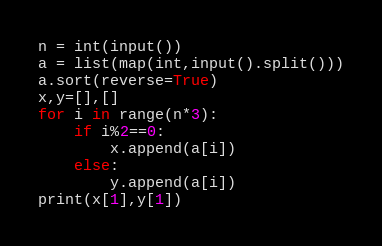<code> <loc_0><loc_0><loc_500><loc_500><_Python_>n = int(input())
a = list(map(int,input().split()))
a.sort(reverse=True)
x,y=[],[]
for i in range(n*3):
    if i%2==0:
        x.append(a[i])
    else:
        y.append(a[i])
print(x[1],y[1])</code> 